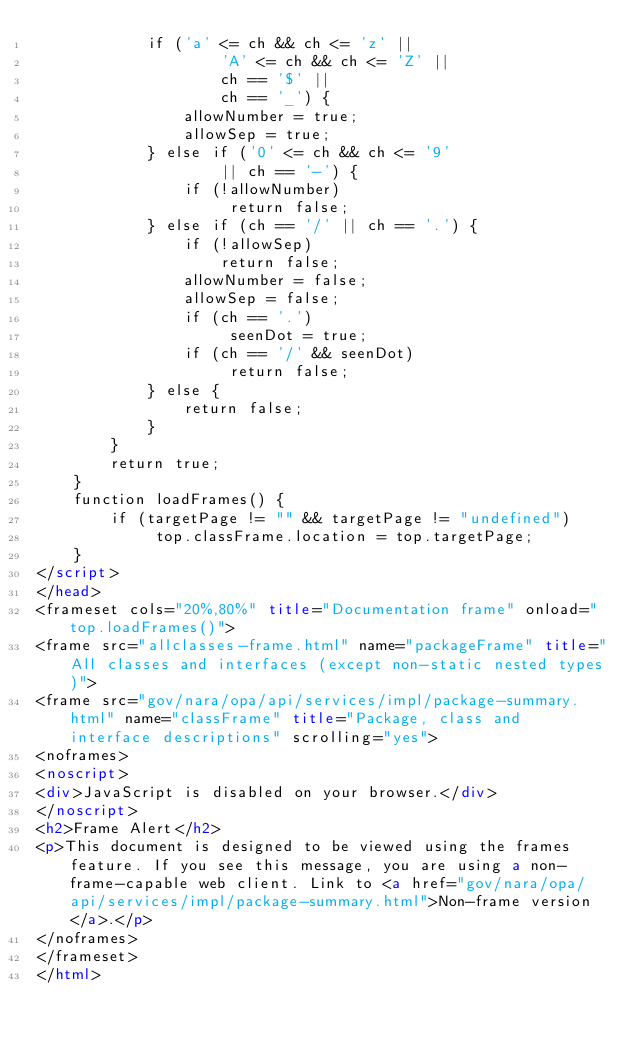Convert code to text. <code><loc_0><loc_0><loc_500><loc_500><_HTML_>            if ('a' <= ch && ch <= 'z' ||
                    'A' <= ch && ch <= 'Z' ||
                    ch == '$' ||
                    ch == '_') {
                allowNumber = true;
                allowSep = true;
            } else if ('0' <= ch && ch <= '9'
                    || ch == '-') {
                if (!allowNumber)
                     return false;
            } else if (ch == '/' || ch == '.') {
                if (!allowSep)
                    return false;
                allowNumber = false;
                allowSep = false;
                if (ch == '.')
                     seenDot = true;
                if (ch == '/' && seenDot)
                     return false;
            } else {
                return false;
            }
        }
        return true;
    }
    function loadFrames() {
        if (targetPage != "" && targetPage != "undefined")
             top.classFrame.location = top.targetPage;
    }
</script>
</head>
<frameset cols="20%,80%" title="Documentation frame" onload="top.loadFrames()">
<frame src="allclasses-frame.html" name="packageFrame" title="All classes and interfaces (except non-static nested types)">
<frame src="gov/nara/opa/api/services/impl/package-summary.html" name="classFrame" title="Package, class and interface descriptions" scrolling="yes">
<noframes>
<noscript>
<div>JavaScript is disabled on your browser.</div>
</noscript>
<h2>Frame Alert</h2>
<p>This document is designed to be viewed using the frames feature. If you see this message, you are using a non-frame-capable web client. Link to <a href="gov/nara/opa/api/services/impl/package-summary.html">Non-frame version</a>.</p>
</noframes>
</frameset>
</html>
</code> 